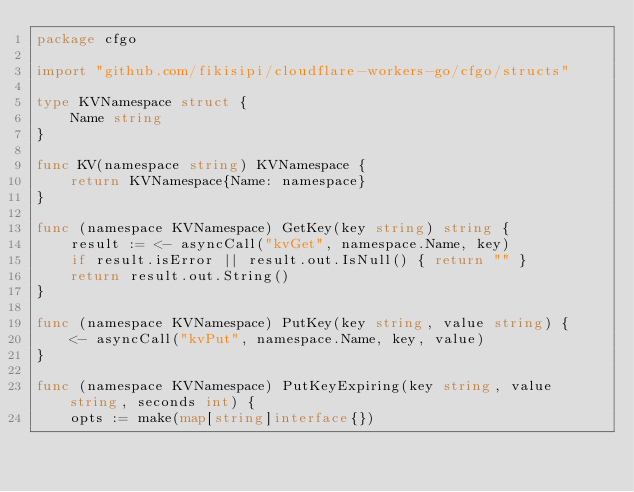Convert code to text. <code><loc_0><loc_0><loc_500><loc_500><_Go_>package cfgo

import "github.com/fikisipi/cloudflare-workers-go/cfgo/structs"

type KVNamespace struct {
	Name string
}

func KV(namespace string) KVNamespace {
	return KVNamespace{Name: namespace}
}

func (namespace KVNamespace) GetKey(key string) string {
	result := <- asyncCall("kvGet", namespace.Name, key)
	if result.isError || result.out.IsNull() { return "" }
	return result.out.String()
}

func (namespace KVNamespace) PutKey(key string, value string) {
	<- asyncCall("kvPut", namespace.Name, key, value)
}

func (namespace KVNamespace) PutKeyExpiring(key string, value string, seconds int) {
	opts := make(map[string]interface{})</code> 